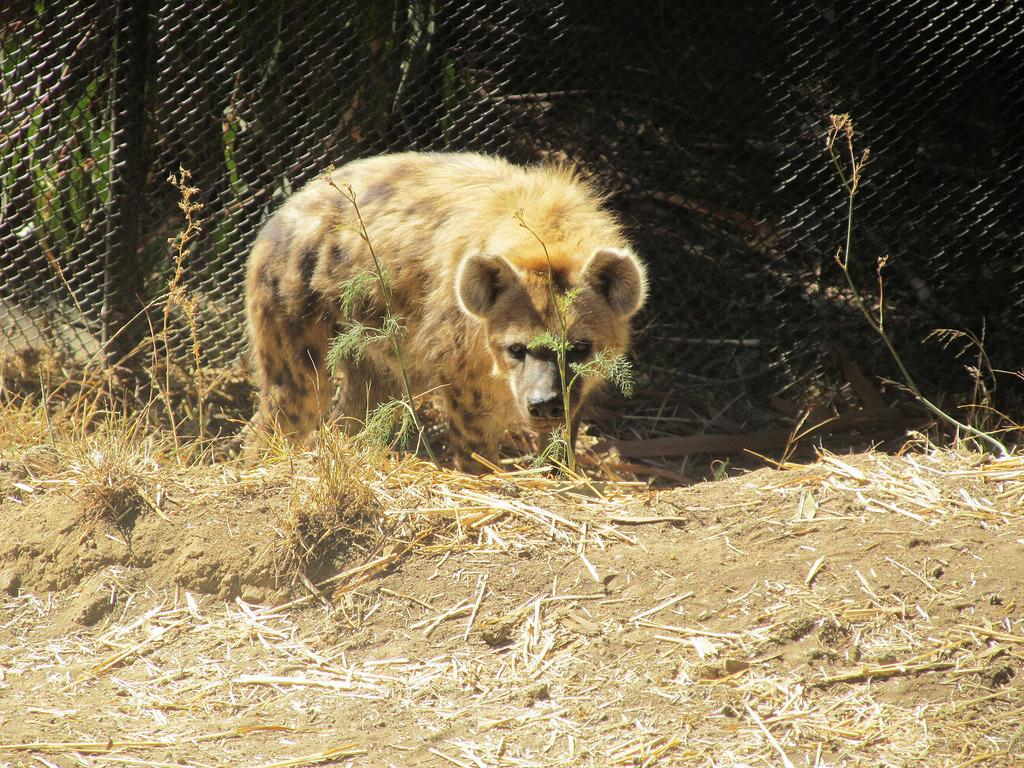What animal is in the foreground of the image? There is a hyena in the foreground of the image. What type of terrain is visible at the bottom of the image? There is land visible at the bottom of the image. What can be seen in the background of the image? There is fencing in the background of the image. What type of pet is sitting on the paper near the lamp in the image? There is no pet, paper, or lamp present in the image; it only features a hyena and fencing. 